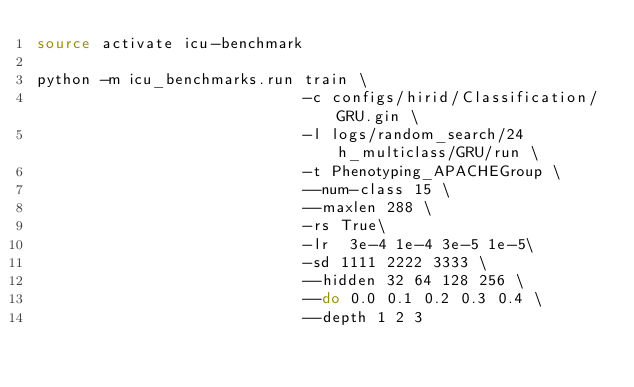Convert code to text. <code><loc_0><loc_0><loc_500><loc_500><_Bash_>source activate icu-benchmark

python -m icu_benchmarks.run train \
                             -c configs/hirid/Classification/GRU.gin \
                             -l logs/random_search/24h_multiclass/GRU/run \
                             -t Phenotyping_APACHEGroup \
                             --num-class 15 \
                             --maxlen 288 \
                             -rs True\
                             -lr  3e-4 1e-4 3e-5 1e-5\
                             -sd 1111 2222 3333 \
                             --hidden 32 64 128 256 \
                             --do 0.0 0.1 0.2 0.3 0.4 \
                             --depth 1 2 3
</code> 